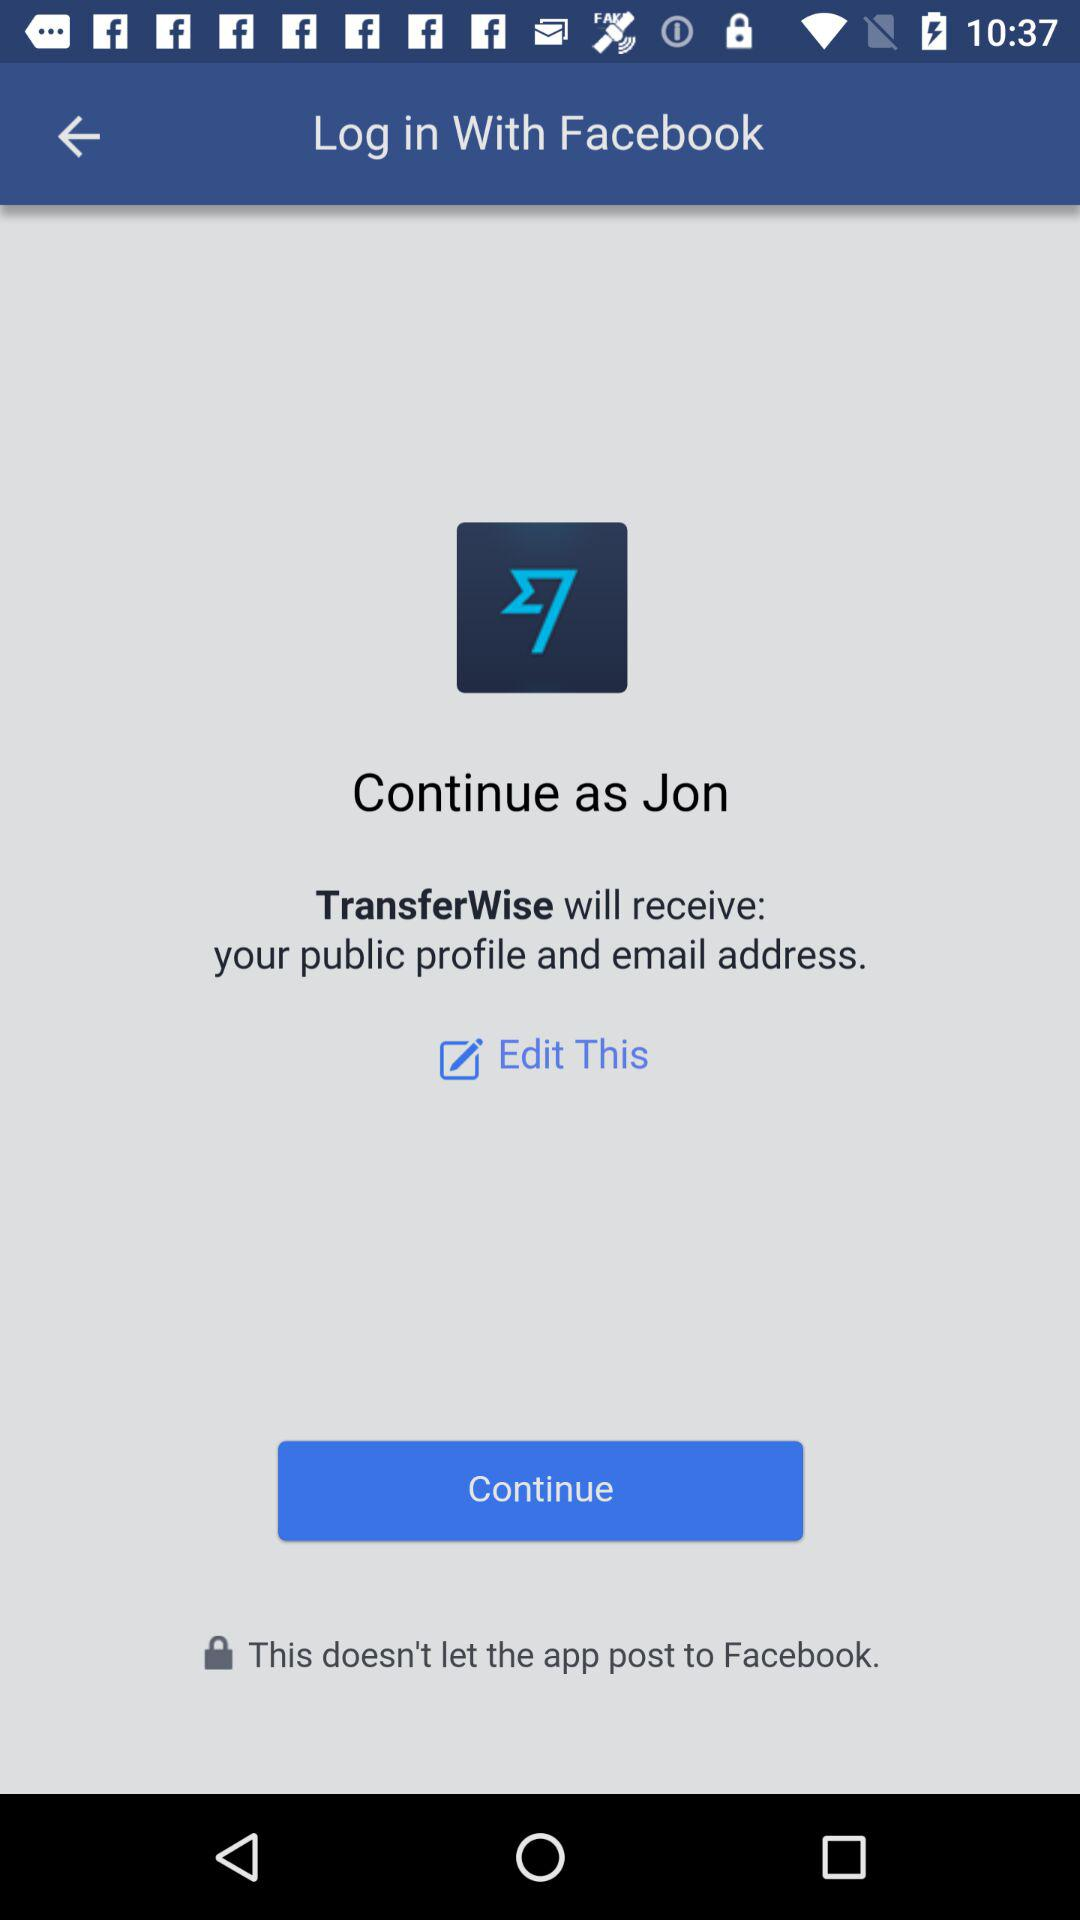What application is asking for permission? The application asking for permission is "TransferWise". 